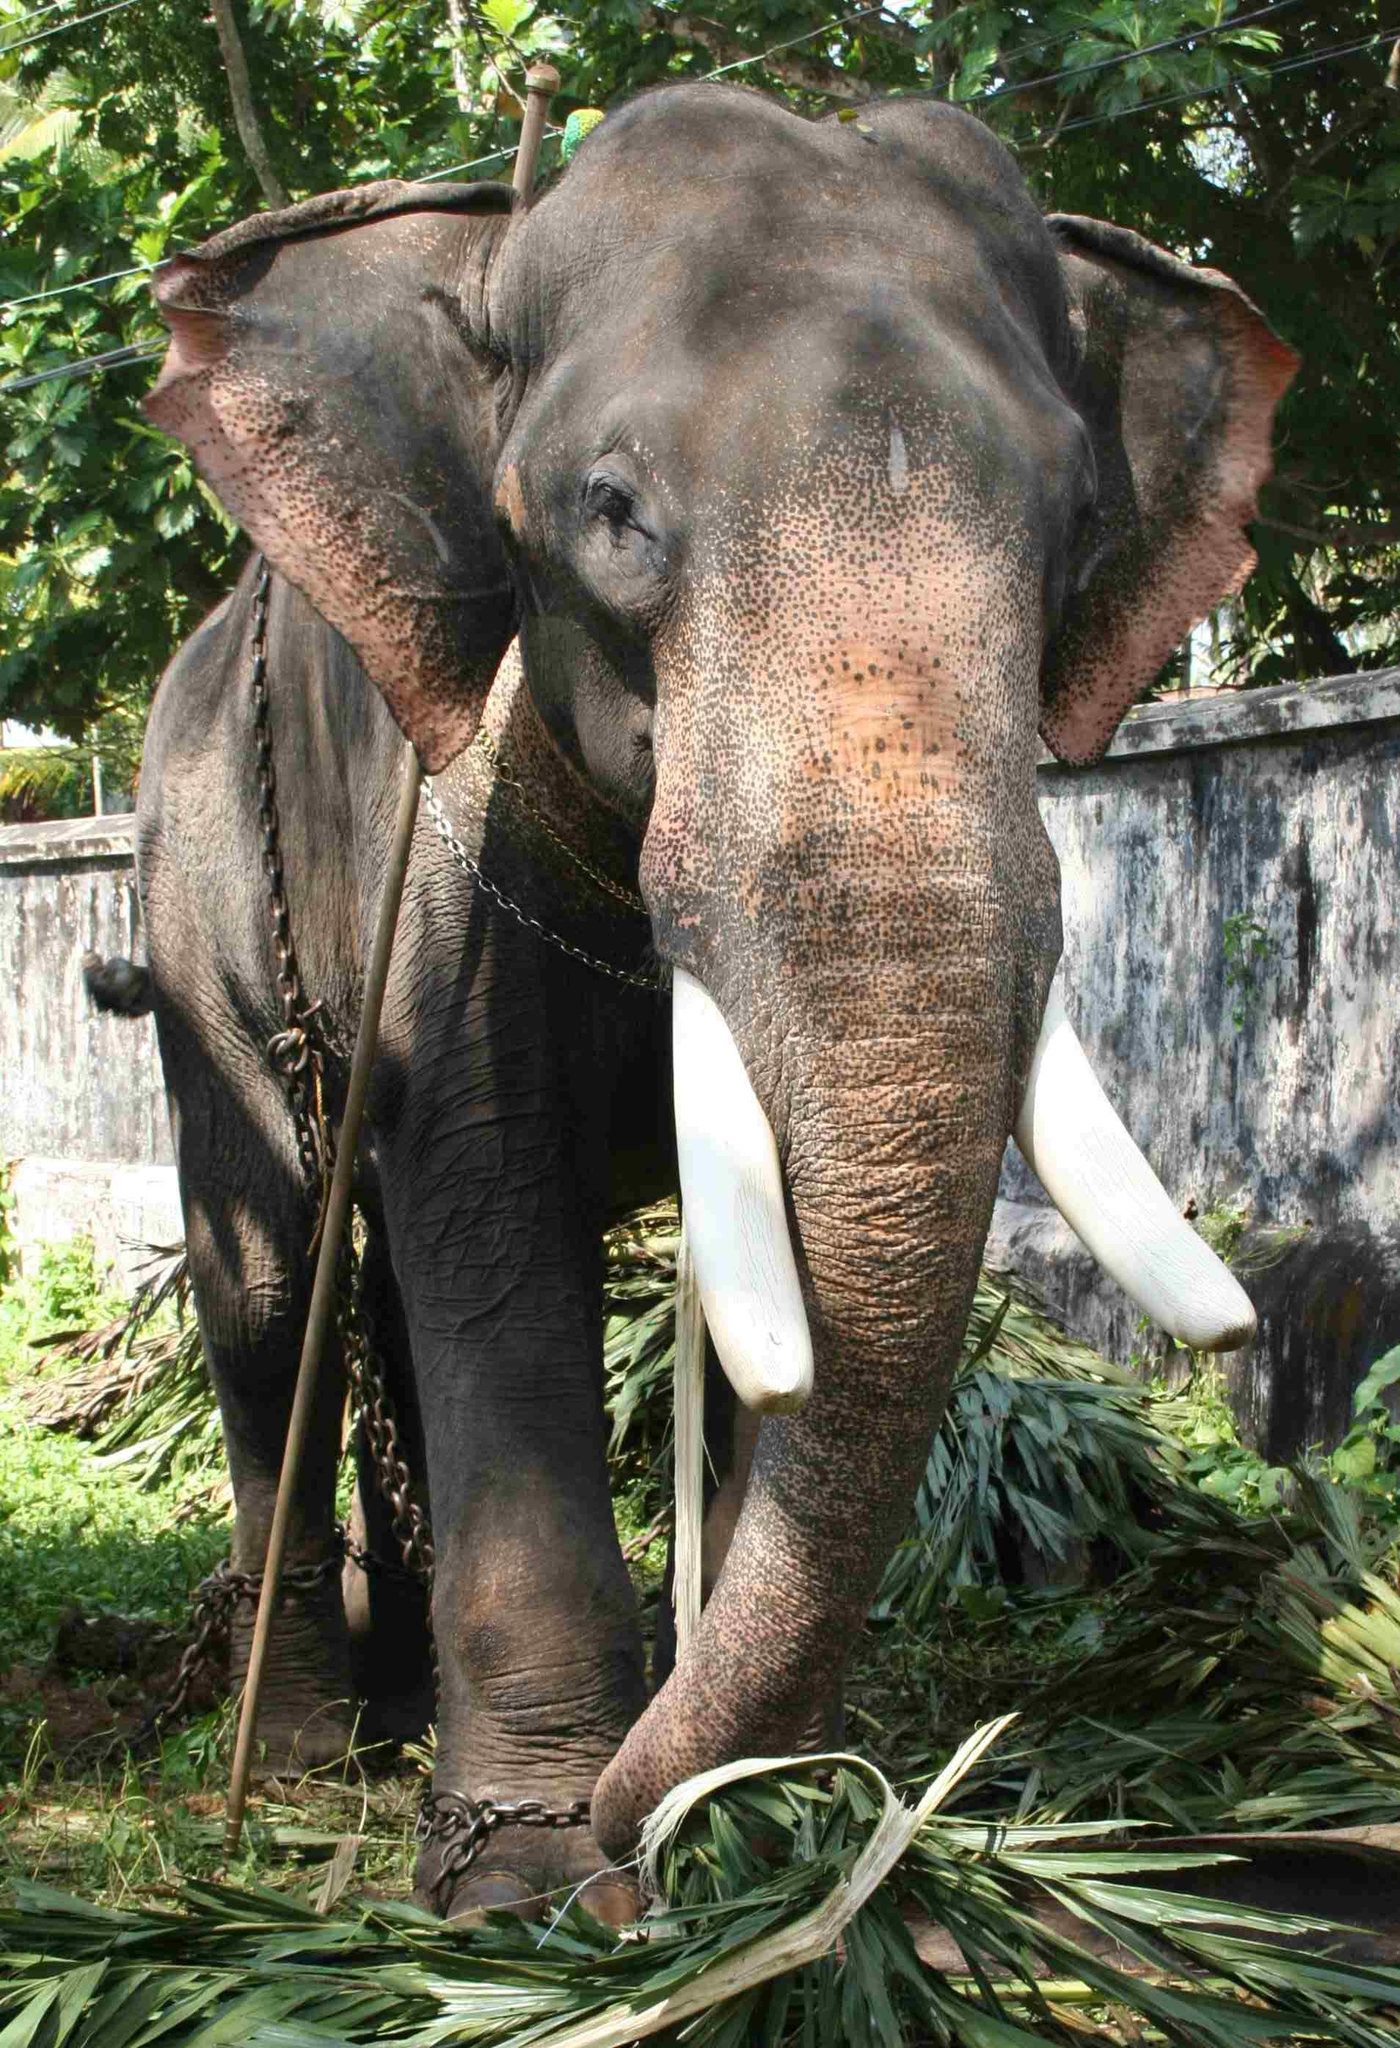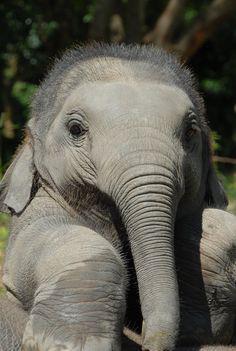The first image is the image on the left, the second image is the image on the right. Analyze the images presented: Is the assertion "Every image shows exactly one elephant that is outdoors." valid? Answer yes or no. Yes. The first image is the image on the left, the second image is the image on the right. For the images displayed, is the sentence "There is at least two elephants in the right image." factually correct? Answer yes or no. No. 